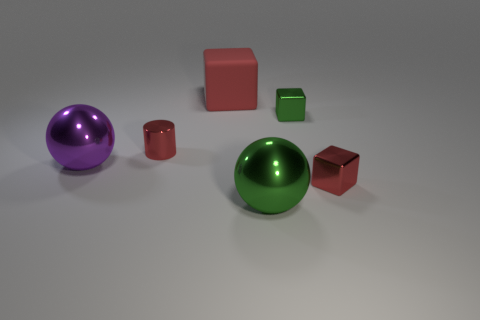There is a shiny thing that is the same size as the purple ball; what color is it?
Provide a succinct answer. Green. Are there any metal objects on the right side of the tiny red metal thing on the left side of the green shiny cube?
Keep it short and to the point. Yes. What is the big ball that is on the right side of the big red matte block made of?
Your answer should be very brief. Metal. Are the sphere to the left of the big block and the red block behind the small shiny cylinder made of the same material?
Offer a very short reply. No. Are there an equal number of small blocks that are in front of the red shiny block and metal cubes on the left side of the green shiny cube?
Your answer should be very brief. Yes. How many big green balls are made of the same material as the red cylinder?
Keep it short and to the point. 1. What is the shape of the shiny object that is the same color as the small shiny cylinder?
Give a very brief answer. Cube. How big is the red metal thing left of the large block behind the tiny red cylinder?
Your answer should be very brief. Small. Does the tiny object that is to the right of the green block have the same shape as the red thing that is behind the tiny red shiny cylinder?
Your answer should be very brief. Yes. Are there an equal number of green metallic objects on the left side of the red cylinder and big green matte cubes?
Your response must be concise. Yes. 